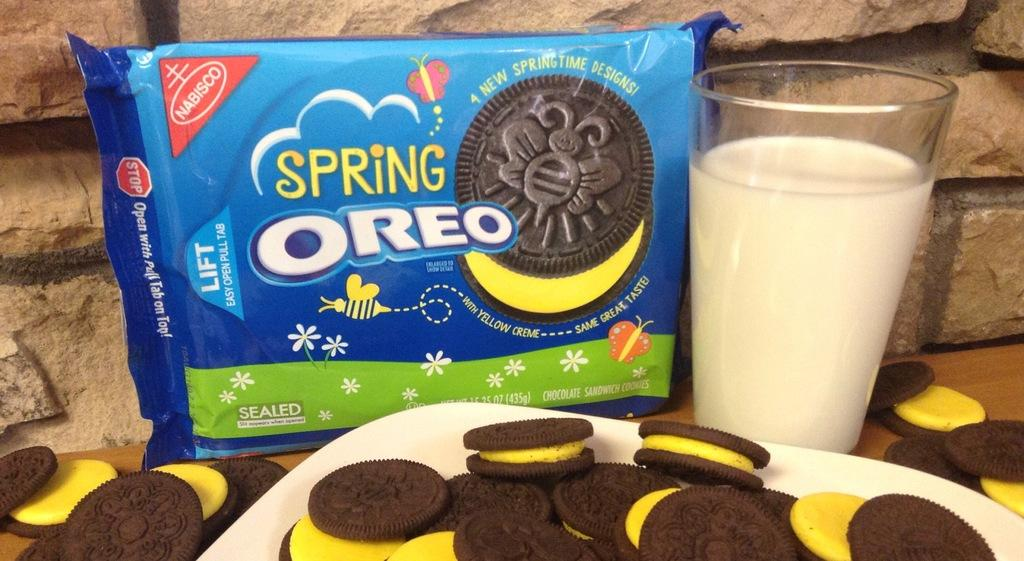What type of food is present in the image? There are biscuits in the image. How are the biscuits arranged or displayed? The biscuits are in plates. What else can be seen in the image besides the biscuits? There is a glass visible in the image. How many ideas are depicted on the canvas in the image? There is no canvas or ideas present in the image; it features biscuits in plates and a glass. 